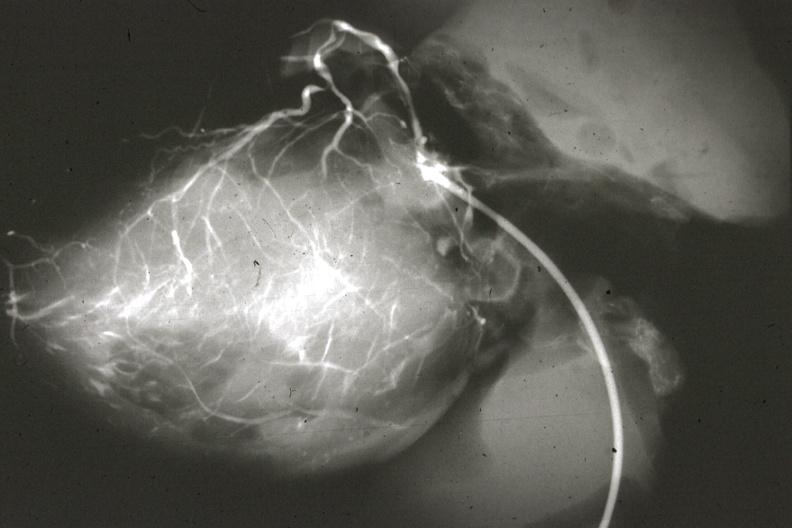does marfans syndrome show angiogram postmortafter switch of left coronary to aorta?
Answer the question using a single word or phrase. No 